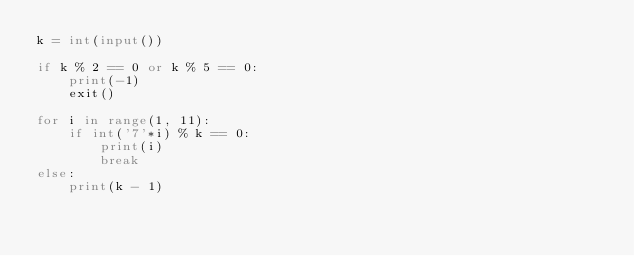Convert code to text. <code><loc_0><loc_0><loc_500><loc_500><_Python_>k = int(input())

if k % 2 == 0 or k % 5 == 0:
    print(-1)
    exit()

for i in range(1, 11):
    if int('7'*i) % k == 0:
        print(i)
        break
else:
    print(k - 1)</code> 